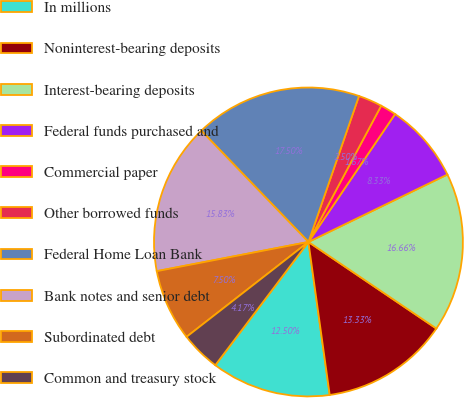<chart> <loc_0><loc_0><loc_500><loc_500><pie_chart><fcel>In millions<fcel>Noninterest-bearing deposits<fcel>Interest-bearing deposits<fcel>Federal funds purchased and<fcel>Commercial paper<fcel>Other borrowed funds<fcel>Federal Home Loan Bank<fcel>Bank notes and senior debt<fcel>Subordinated debt<fcel>Common and treasury stock<nl><fcel>12.5%<fcel>13.33%<fcel>16.66%<fcel>8.33%<fcel>1.67%<fcel>2.5%<fcel>17.5%<fcel>15.83%<fcel>7.5%<fcel>4.17%<nl></chart> 